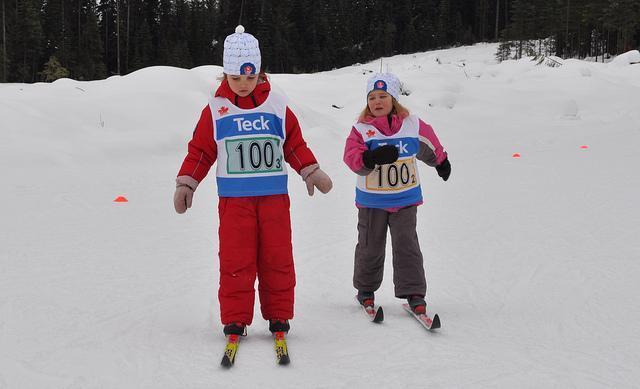How many people are wearing hats?
Give a very brief answer. 2. How many people are in the picture?
Give a very brief answer. 2. How many horses are at the fence?
Give a very brief answer. 0. 